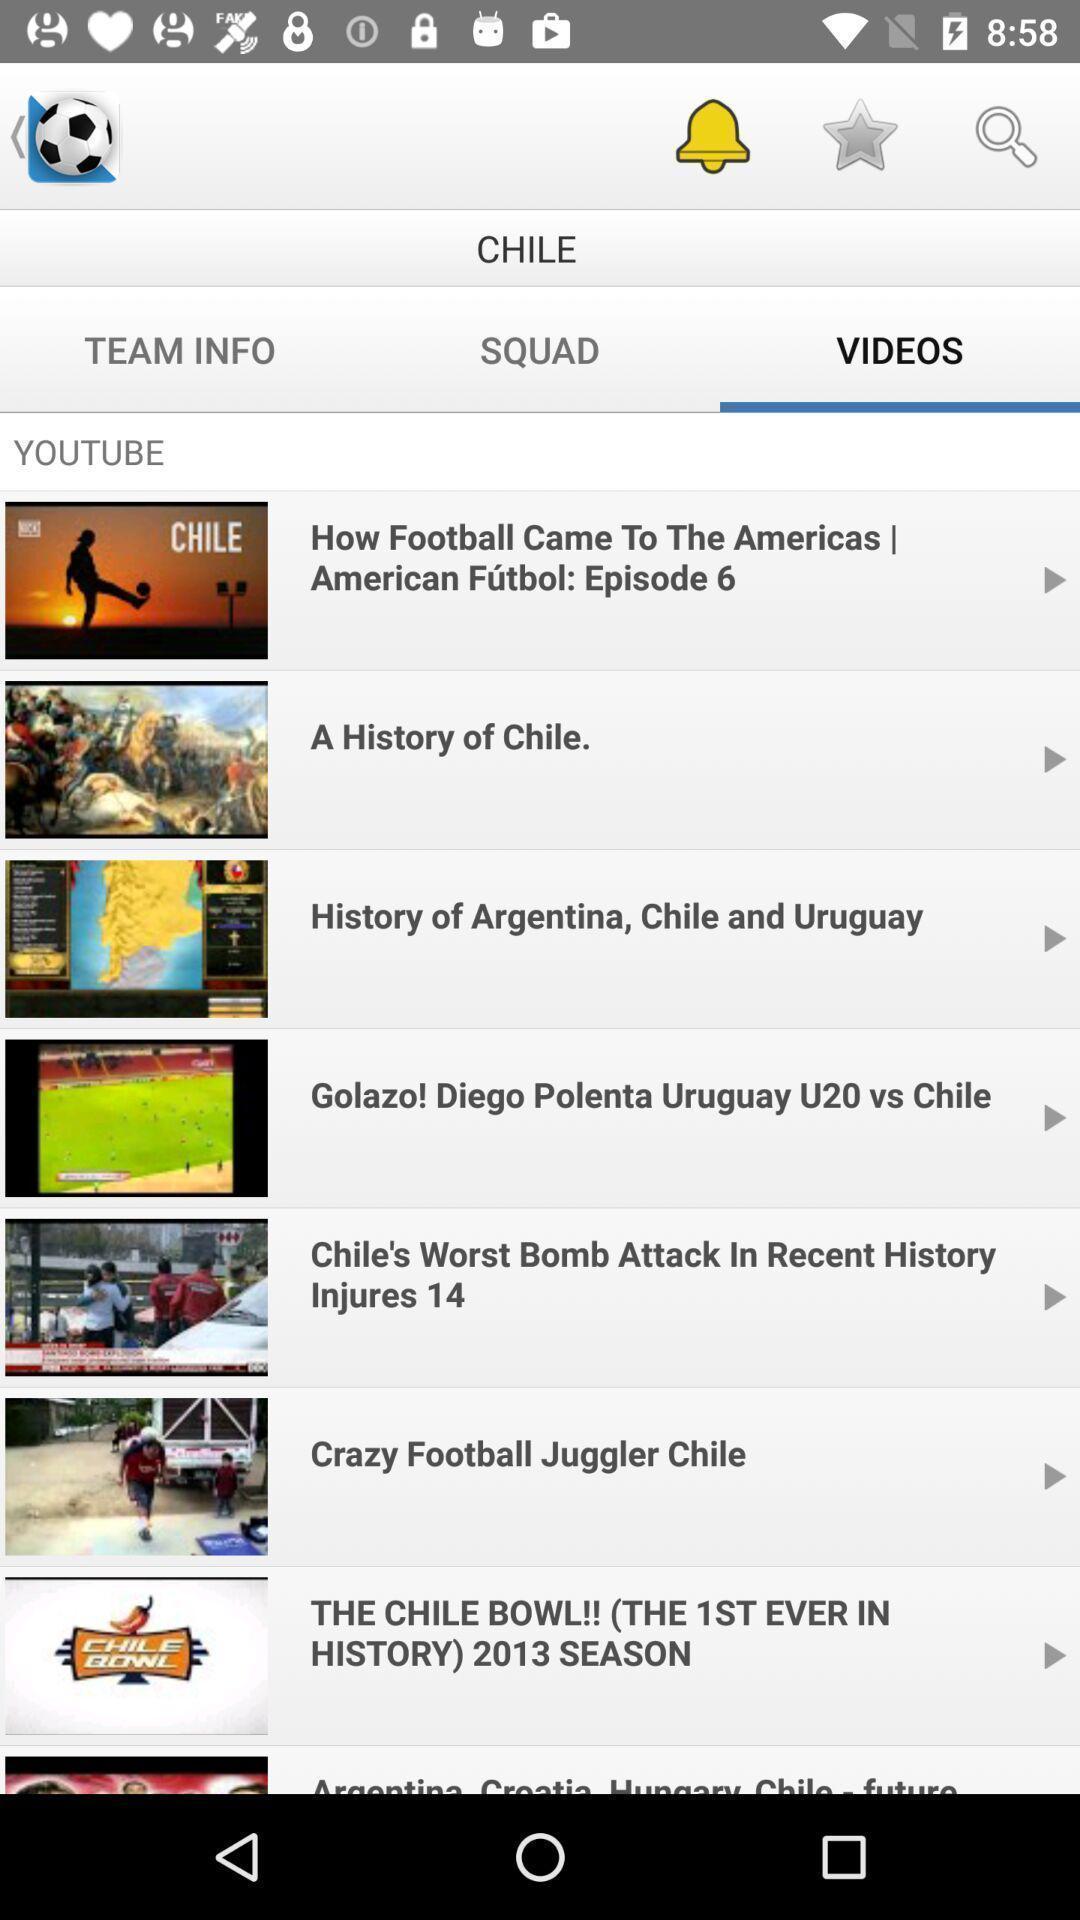Tell me about the visual elements in this screen capture. Screen showing videos. 